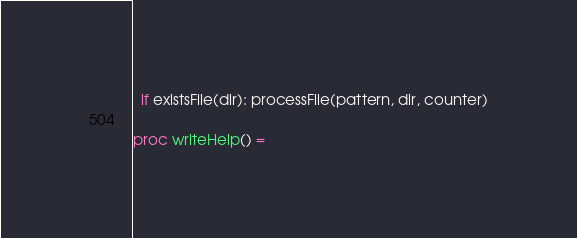Convert code to text. <code><loc_0><loc_0><loc_500><loc_500><_Nim_>  if existsFile(dir): processFile(pattern, dir, counter)

proc writeHelp() =</code> 